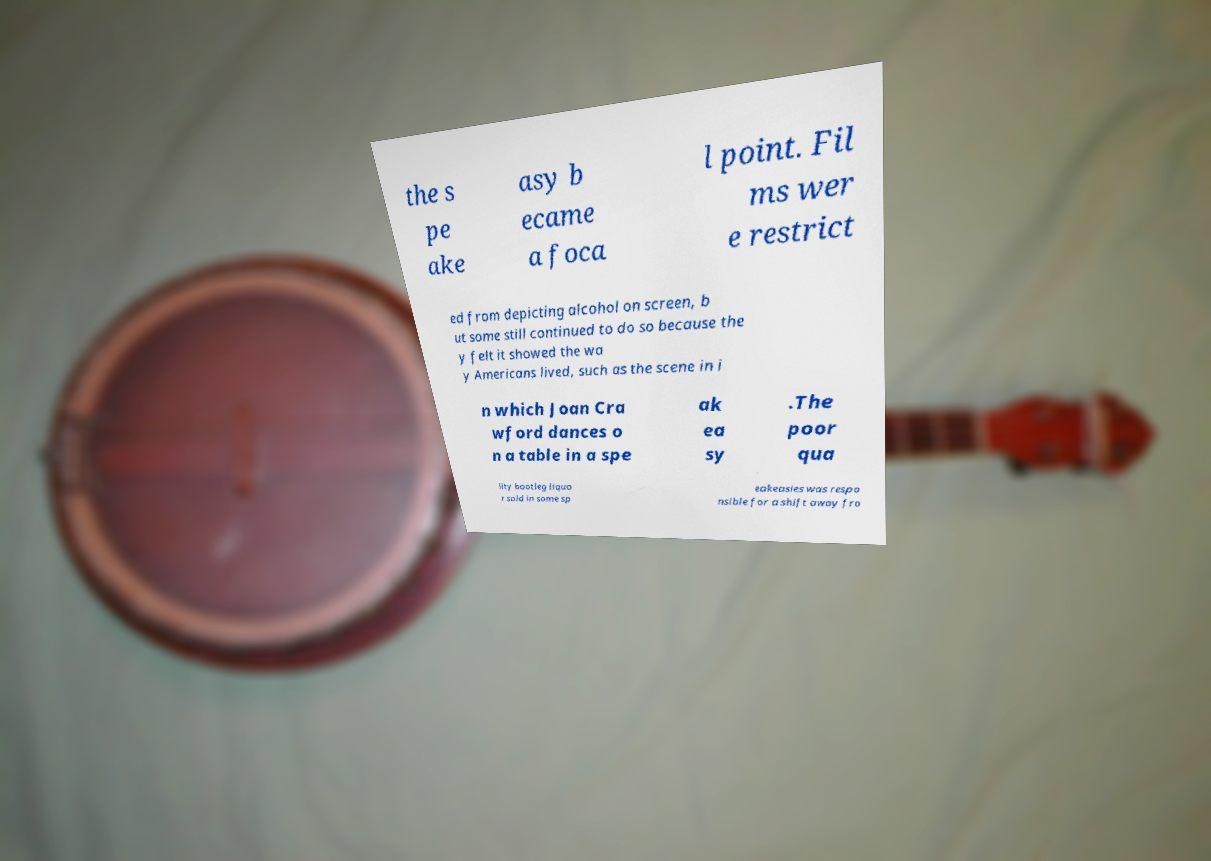Can you accurately transcribe the text from the provided image for me? the s pe ake asy b ecame a foca l point. Fil ms wer e restrict ed from depicting alcohol on screen, b ut some still continued to do so because the y felt it showed the wa y Americans lived, such as the scene in i n which Joan Cra wford dances o n a table in a spe ak ea sy .The poor qua lity bootleg liquo r sold in some sp eakeasies was respo nsible for a shift away fro 